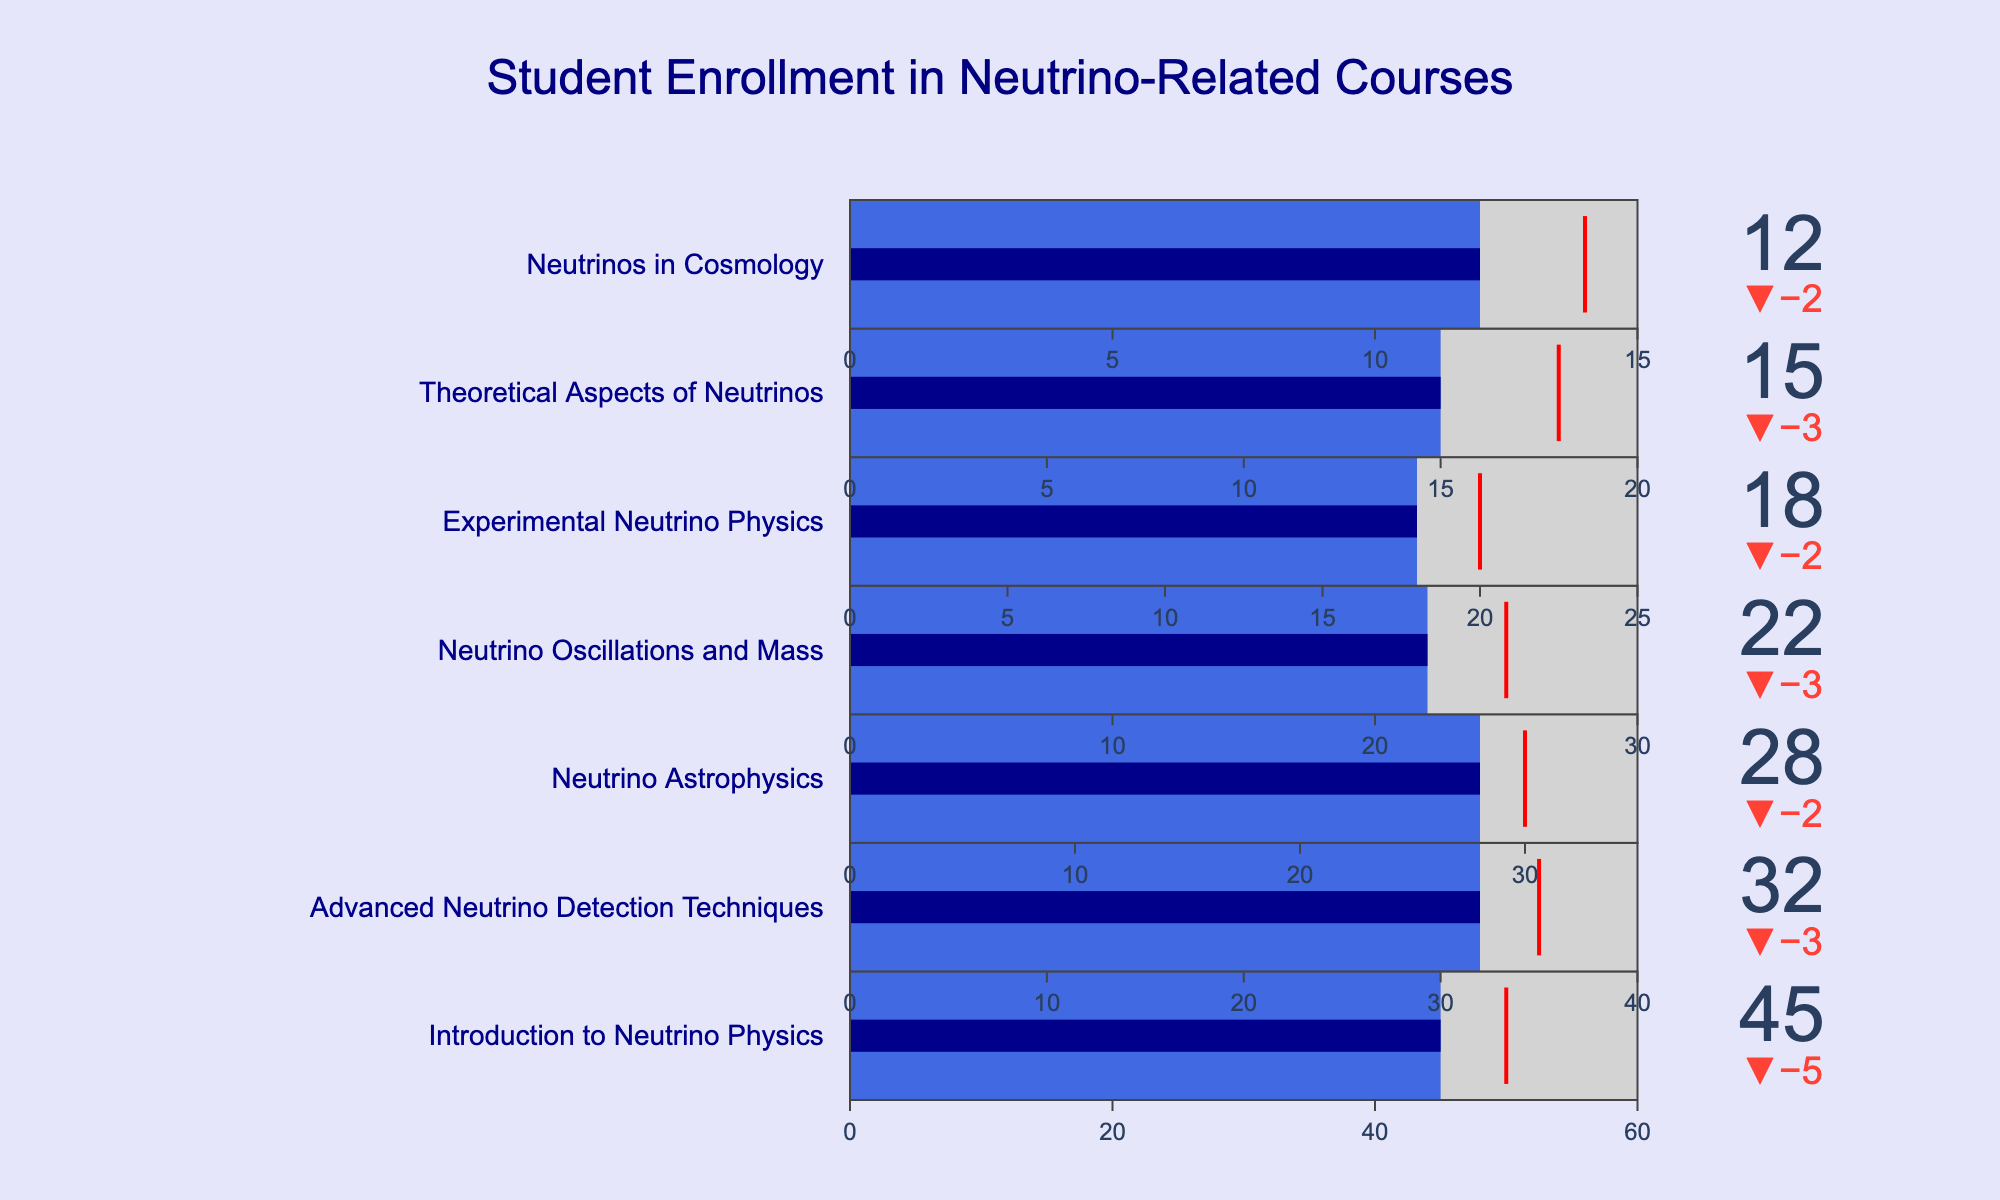What's the title of the chart? The title is prominently displayed at the top of the figure.
Answer: Student Enrollment in Neutrino-Related Courses How many courses have enrollment numbers meeting or exceeding their target? By evaluating the delta indicators for each course, we find that "Introduction to Neutrino Physics," "Neutrino Astrophysics," and "Neutrino Oscillations and Mass" meet or exceed their target.
Answer: 3 What is the highest enrollment count among the courses? The enrollment for each course can be seen next to each bullet gauge. The highest enrollment count is for "Introduction to Neutrino Physics" with 45 students.
Answer: 45 Which course has the smallest difference between enrolled students and target? By comparing `Enrolled - Target` for each course, we see "Introduction to Neutrino Physics" has the smallest difference of 45 - 50 = -5.
Answer: Introduction to Neutrino Physics What is the total capacity for all courses combined? Sum the capacity values: 60 + 40 + 35 + 30 + 25 + 20 + 15 = 225.
Answer: 225 How many more students can "Experimental Neutrino Physics" enroll to reach its capacity? The current enrollment is 18 and the capacity is 25. Subtract 18 from 25: 25 - 18 = 7.
Answer: 7 Which course has an enrollment furthest below its target? By comparing `Target - Enrolled` for all courses, "Neutrinos in Cosmology" shows the largest gap with 14 - 12 = 2.
Answer: Neutrinos in Cosmology Is the current enrollment in "Advanced Neutrino Detection Techniques" above, below, or at the target? The target for this course is 35 and the enrollment is 32. Since 32 is less than 35, it's below the target.
Answer: Below In which course is the enrolled number exactly on the target? By checking for courses where `Enrolled = Target`, we find none of the courses have this exact match.
Answer: None Calculate the average enrollment across all courses. Sum of enrollments: 45 + 32 + 28 + 22 + 18 + 15 + 12 = 172. Divide by the number of courses (7): 172 / 7 ≈ 24.57.
Answer: 24.57 